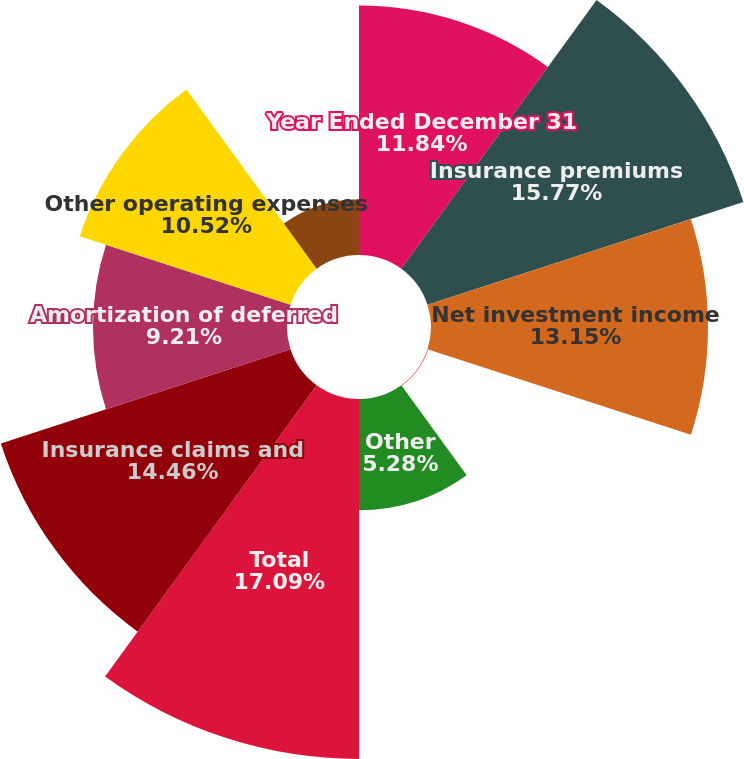Convert chart to OTSL. <chart><loc_0><loc_0><loc_500><loc_500><pie_chart><fcel>Year Ended December 31<fcel>Insurance premiums<fcel>Net investment income<fcel>Investment gains (losses)<fcel>Other<fcel>Total<fcel>Insurance claims and<fcel>Amortization of deferred<fcel>Other operating expenses<fcel>Interest<nl><fcel>11.84%<fcel>15.77%<fcel>13.15%<fcel>0.03%<fcel>5.28%<fcel>17.09%<fcel>14.46%<fcel>9.21%<fcel>10.52%<fcel>2.65%<nl></chart> 